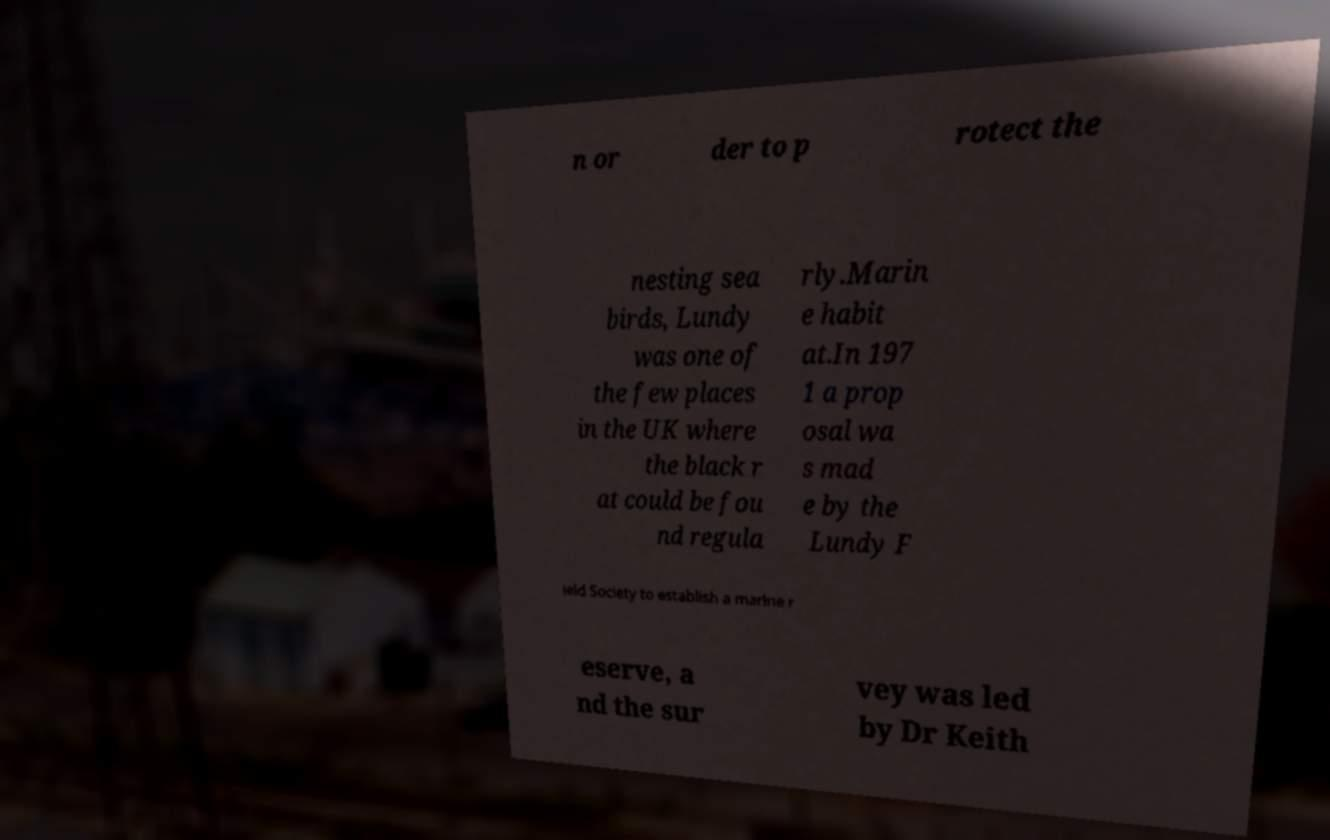Can you read and provide the text displayed in the image?This photo seems to have some interesting text. Can you extract and type it out for me? n or der to p rotect the nesting sea birds, Lundy was one of the few places in the UK where the black r at could be fou nd regula rly.Marin e habit at.In 197 1 a prop osal wa s mad e by the Lundy F ield Society to establish a marine r eserve, a nd the sur vey was led by Dr Keith 